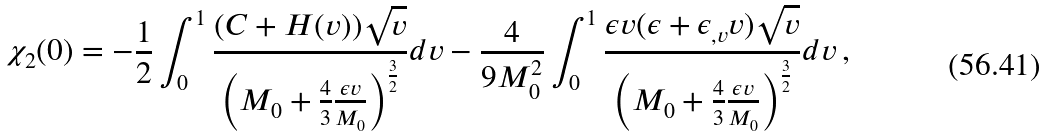<formula> <loc_0><loc_0><loc_500><loc_500>\chi _ { 2 } ( 0 ) = - \frac { 1 } { 2 } \int ^ { 1 } _ { 0 } \frac { ( C + H ( v ) ) \sqrt { v } } { \left ( M _ { 0 } + \frac { 4 } { 3 } \frac { \epsilon v } { M _ { 0 } } \right ) ^ { \frac { 3 } { 2 } } } d v - \frac { 4 } { 9 M _ { 0 } ^ { 2 } } \int ^ { 1 } _ { 0 } \frac { \epsilon v ( \epsilon + \epsilon _ { , v } v ) \sqrt { v } } { \left ( M _ { 0 } + \frac { 4 } { 3 } \frac { \epsilon v } { M _ { 0 } } \right ) ^ { \frac { 3 } { 2 } } } d v \, ,</formula> 